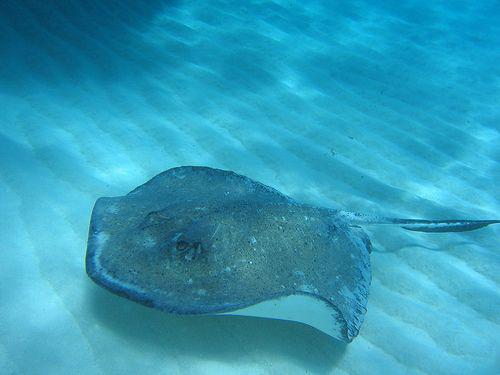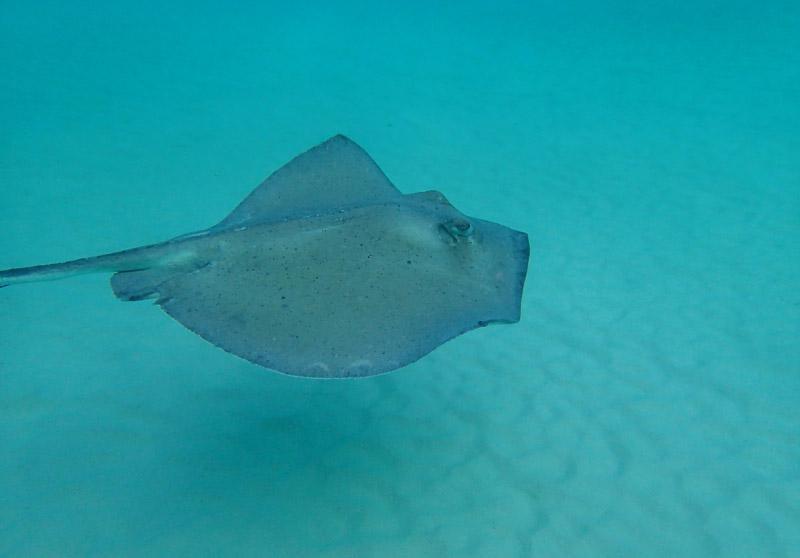The first image is the image on the left, the second image is the image on the right. Assess this claim about the two images: "The left image contains a sting ray that is swimming slightly upwards towards the right.". Correct or not? Answer yes or no. No. The first image is the image on the left, the second image is the image on the right. Evaluate the accuracy of this statement regarding the images: "Each image contains a single stingray, and the stingrays in the right and left images face opposite direction.". Is it true? Answer yes or no. Yes. 